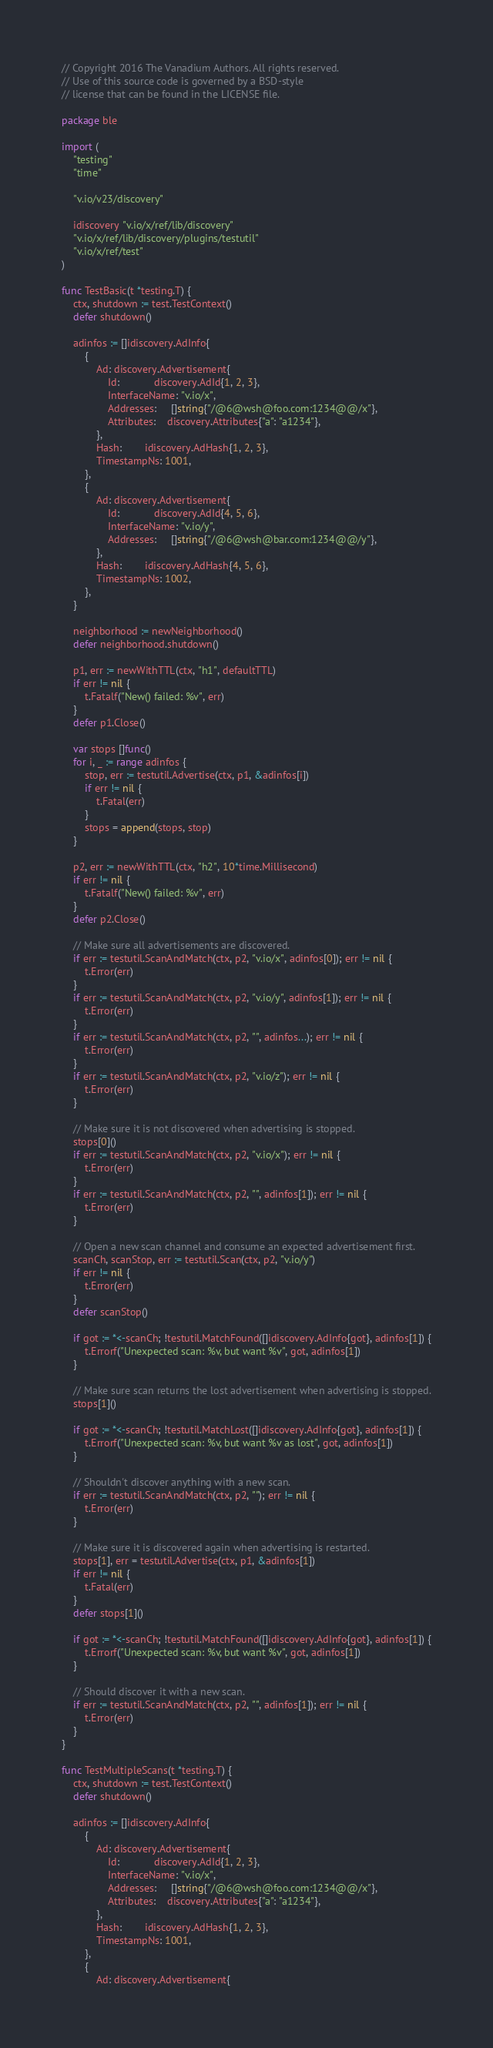Convert code to text. <code><loc_0><loc_0><loc_500><loc_500><_Go_>// Copyright 2016 The Vanadium Authors. All rights reserved.
// Use of this source code is governed by a BSD-style
// license that can be found in the LICENSE file.

package ble

import (
	"testing"
	"time"

	"v.io/v23/discovery"

	idiscovery "v.io/x/ref/lib/discovery"
	"v.io/x/ref/lib/discovery/plugins/testutil"
	"v.io/x/ref/test"
)

func TestBasic(t *testing.T) {
	ctx, shutdown := test.TestContext()
	defer shutdown()

	adinfos := []idiscovery.AdInfo{
		{
			Ad: discovery.Advertisement{
				Id:            discovery.AdId{1, 2, 3},
				InterfaceName: "v.io/x",
				Addresses:     []string{"/@6@wsh@foo.com:1234@@/x"},
				Attributes:    discovery.Attributes{"a": "a1234"},
			},
			Hash:        idiscovery.AdHash{1, 2, 3},
			TimestampNs: 1001,
		},
		{
			Ad: discovery.Advertisement{
				Id:            discovery.AdId{4, 5, 6},
				InterfaceName: "v.io/y",
				Addresses:     []string{"/@6@wsh@bar.com:1234@@/y"},
			},
			Hash:        idiscovery.AdHash{4, 5, 6},
			TimestampNs: 1002,
		},
	}

	neighborhood := newNeighborhood()
	defer neighborhood.shutdown()

	p1, err := newWithTTL(ctx, "h1", defaultTTL)
	if err != nil {
		t.Fatalf("New() failed: %v", err)
	}
	defer p1.Close()

	var stops []func()
	for i, _ := range adinfos {
		stop, err := testutil.Advertise(ctx, p1, &adinfos[i])
		if err != nil {
			t.Fatal(err)
		}
		stops = append(stops, stop)
	}

	p2, err := newWithTTL(ctx, "h2", 10*time.Millisecond)
	if err != nil {
		t.Fatalf("New() failed: %v", err)
	}
	defer p2.Close()

	// Make sure all advertisements are discovered.
	if err := testutil.ScanAndMatch(ctx, p2, "v.io/x", adinfos[0]); err != nil {
		t.Error(err)
	}
	if err := testutil.ScanAndMatch(ctx, p2, "v.io/y", adinfos[1]); err != nil {
		t.Error(err)
	}
	if err := testutil.ScanAndMatch(ctx, p2, "", adinfos...); err != nil {
		t.Error(err)
	}
	if err := testutil.ScanAndMatch(ctx, p2, "v.io/z"); err != nil {
		t.Error(err)
	}

	// Make sure it is not discovered when advertising is stopped.
	stops[0]()
	if err := testutil.ScanAndMatch(ctx, p2, "v.io/x"); err != nil {
		t.Error(err)
	}
	if err := testutil.ScanAndMatch(ctx, p2, "", adinfos[1]); err != nil {
		t.Error(err)
	}

	// Open a new scan channel and consume an expected advertisement first.
	scanCh, scanStop, err := testutil.Scan(ctx, p2, "v.io/y")
	if err != nil {
		t.Error(err)
	}
	defer scanStop()

	if got := *<-scanCh; !testutil.MatchFound([]idiscovery.AdInfo{got}, adinfos[1]) {
		t.Errorf("Unexpected scan: %v, but want %v", got, adinfos[1])
	}

	// Make sure scan returns the lost advertisement when advertising is stopped.
	stops[1]()

	if got := *<-scanCh; !testutil.MatchLost([]idiscovery.AdInfo{got}, adinfos[1]) {
		t.Errorf("Unexpected scan: %v, but want %v as lost", got, adinfos[1])
	}

	// Shouldn't discover anything with a new scan.
	if err := testutil.ScanAndMatch(ctx, p2, ""); err != nil {
		t.Error(err)
	}

	// Make sure it is discovered again when advertising is restarted.
	stops[1], err = testutil.Advertise(ctx, p1, &adinfos[1])
	if err != nil {
		t.Fatal(err)
	}
	defer stops[1]()

	if got := *<-scanCh; !testutil.MatchFound([]idiscovery.AdInfo{got}, adinfos[1]) {
		t.Errorf("Unexpected scan: %v, but want %v", got, adinfos[1])
	}

	// Should discover it with a new scan.
	if err := testutil.ScanAndMatch(ctx, p2, "", adinfos[1]); err != nil {
		t.Error(err)
	}
}

func TestMultipleScans(t *testing.T) {
	ctx, shutdown := test.TestContext()
	defer shutdown()

	adinfos := []idiscovery.AdInfo{
		{
			Ad: discovery.Advertisement{
				Id:            discovery.AdId{1, 2, 3},
				InterfaceName: "v.io/x",
				Addresses:     []string{"/@6@wsh@foo.com:1234@@/x"},
				Attributes:    discovery.Attributes{"a": "a1234"},
			},
			Hash:        idiscovery.AdHash{1, 2, 3},
			TimestampNs: 1001,
		},
		{
			Ad: discovery.Advertisement{</code> 